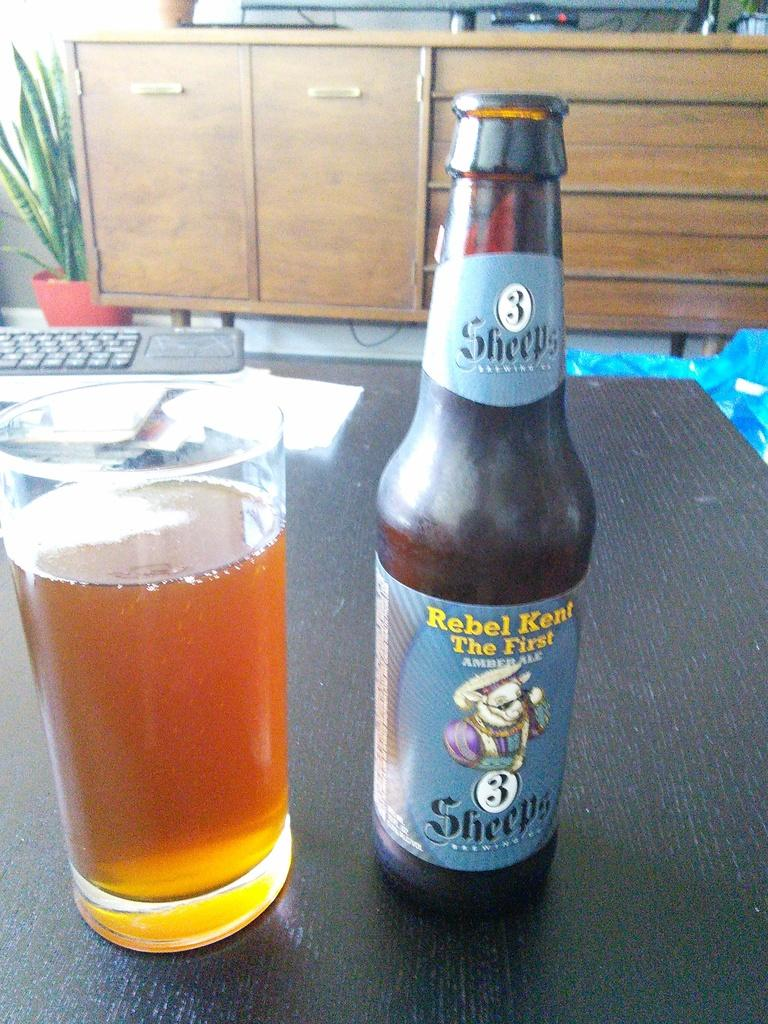<image>
Relay a brief, clear account of the picture shown. A bottle of Rebel Kent Amber Ale next to a glass of the ale on a table. 